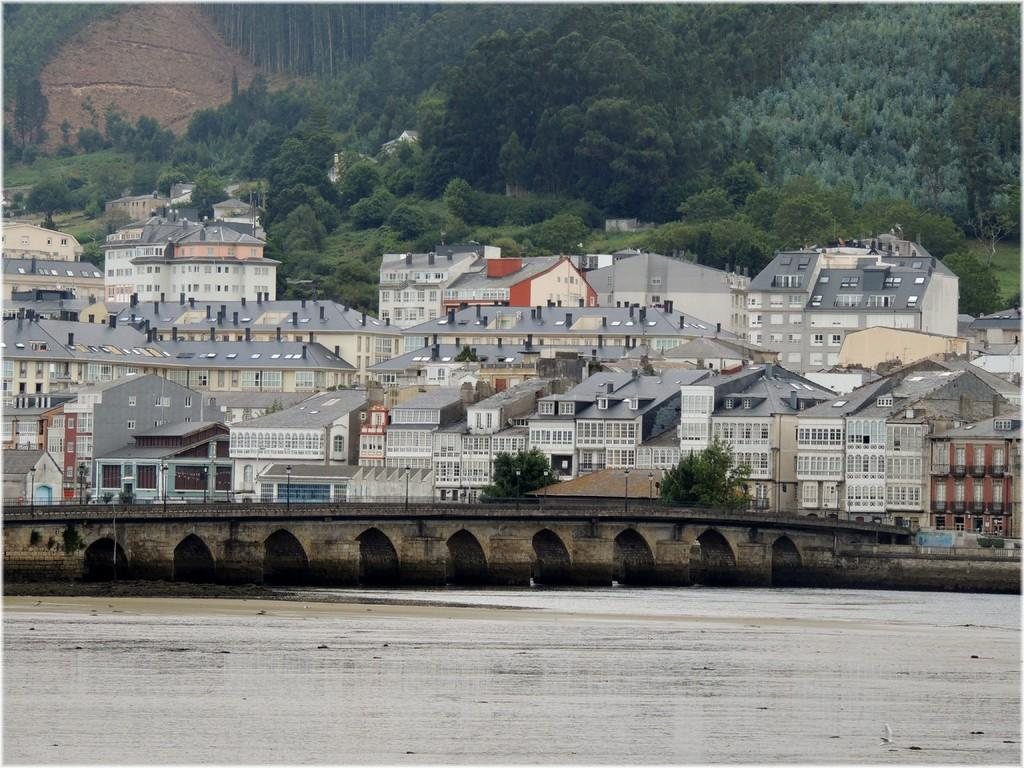What type of structures can be seen in the image? There are roofs of houses in the image. What other natural elements are present in the image? There are trees in the image. What man-made structure can be seen crossing over the water? There is a bridge in the image. What are the light sources in the image? There are light poles in the image, which are used to illuminate the area at night or during low light conditions. By mentioning the roofs of houses, trees, bridge, and light poles, we cover the main subjects and objects in the image based on the provided facts. We then formulate questions that focus on the location and characteristics of these subjects and objects, ensuring that each question can be answered definitively with the information given. We avoid yes/no questions and ensure that the language is simple and clear. Absurd Question/Answer: What caption is written on the bridge in the image? There is no caption visible on the bridge in the image. What discovery was made by the person walking on the bridge in the image? There is no person walking on the bridge in the image, and therefore no discovery can be made. How many legs does the tree in the image have? Trees do not have legs; they have trunks and branches. The image does not show any legs on the tree. 